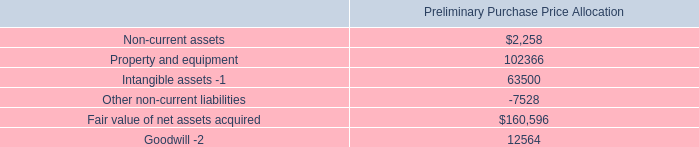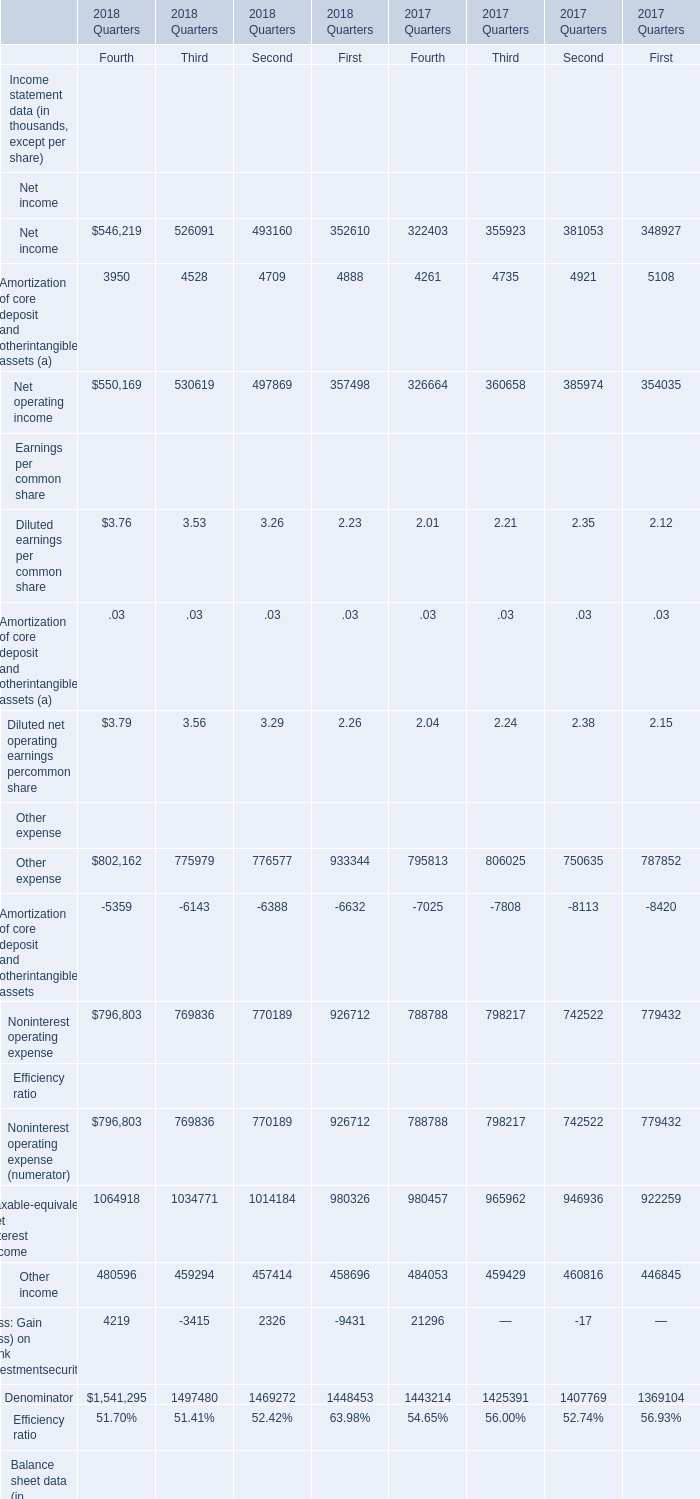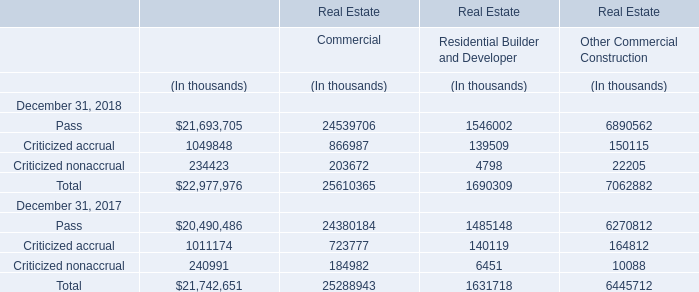What is the growing rate of Deferred taxes in the year with the least Net operating income? 
Computations: (((((13 + 14) + 17) + 18) - (((26 + 32) + 35) + 39)) / (((26 + 32) + 35) + 39))
Answer: -0.5303. 